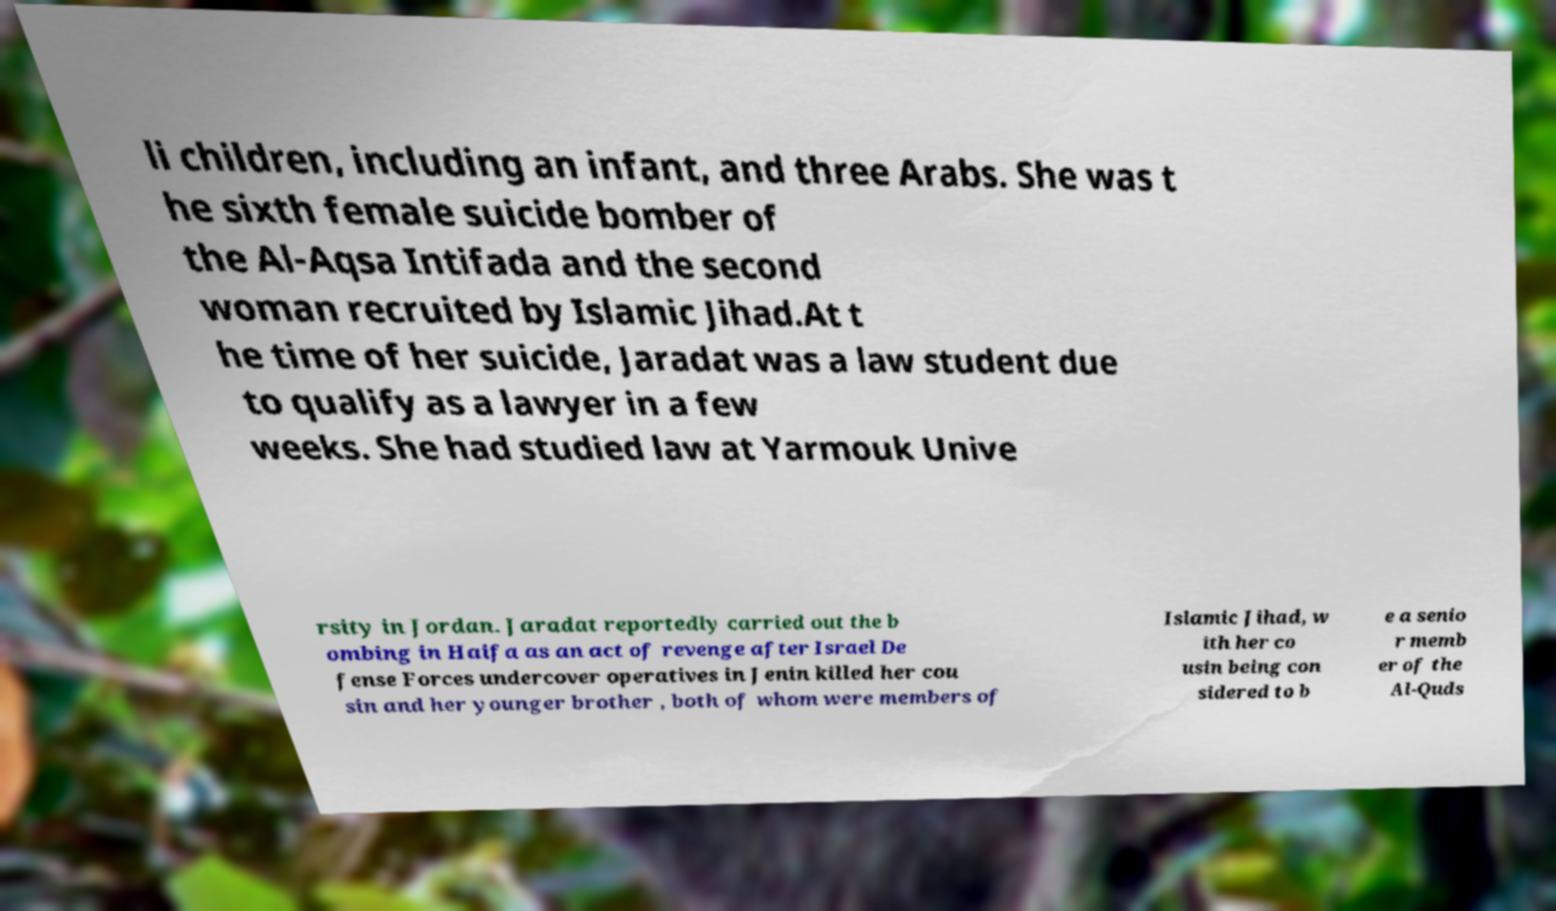Please read and relay the text visible in this image. What does it say? li children, including an infant, and three Arabs. She was t he sixth female suicide bomber of the Al-Aqsa Intifada and the second woman recruited by Islamic Jihad.At t he time of her suicide, Jaradat was a law student due to qualify as a lawyer in a few weeks. She had studied law at Yarmouk Unive rsity in Jordan. Jaradat reportedly carried out the b ombing in Haifa as an act of revenge after Israel De fense Forces undercover operatives in Jenin killed her cou sin and her younger brother , both of whom were members of Islamic Jihad, w ith her co usin being con sidered to b e a senio r memb er of the Al-Quds 